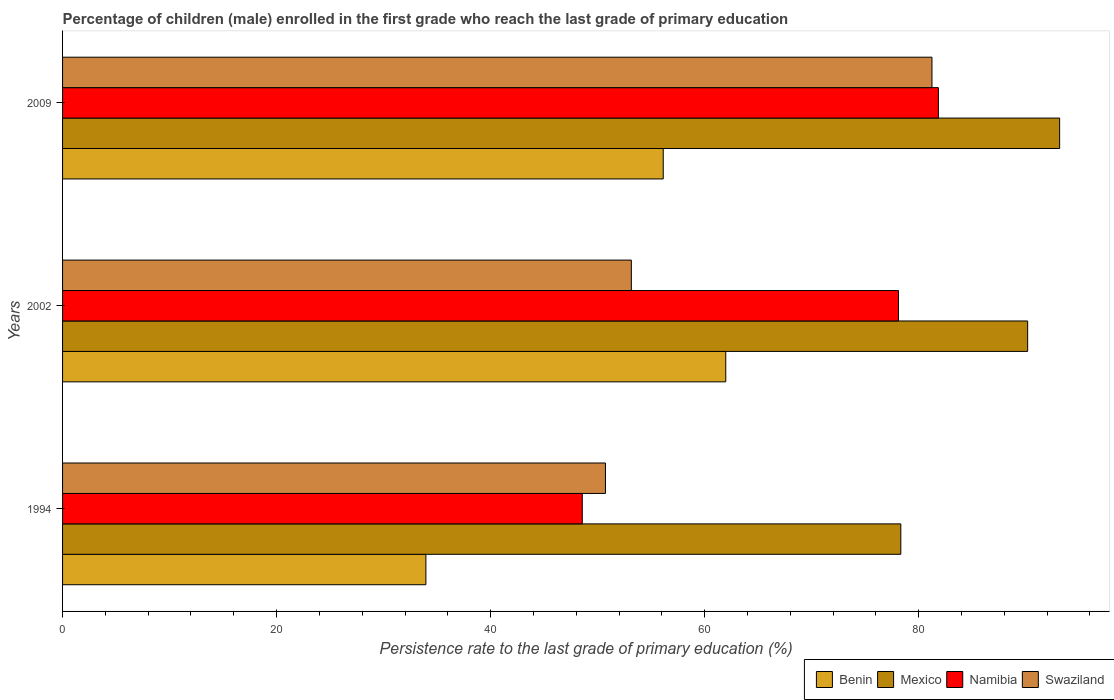How many different coloured bars are there?
Your answer should be compact. 4. Are the number of bars on each tick of the Y-axis equal?
Give a very brief answer. Yes. How many bars are there on the 2nd tick from the top?
Keep it short and to the point. 4. What is the label of the 3rd group of bars from the top?
Provide a short and direct response. 1994. In how many cases, is the number of bars for a given year not equal to the number of legend labels?
Provide a succinct answer. 0. What is the persistence rate of children in Namibia in 2002?
Offer a very short reply. 78.11. Across all years, what is the maximum persistence rate of children in Swaziland?
Offer a very short reply. 81.24. Across all years, what is the minimum persistence rate of children in Mexico?
Give a very brief answer. 78.33. In which year was the persistence rate of children in Swaziland maximum?
Your answer should be compact. 2009. In which year was the persistence rate of children in Benin minimum?
Offer a very short reply. 1994. What is the total persistence rate of children in Swaziland in the graph?
Offer a terse response. 185.12. What is the difference between the persistence rate of children in Benin in 1994 and that in 2009?
Make the answer very short. -22.18. What is the difference between the persistence rate of children in Namibia in 1994 and the persistence rate of children in Mexico in 2009?
Your answer should be compact. -44.61. What is the average persistence rate of children in Benin per year?
Offer a terse response. 50.68. In the year 2009, what is the difference between the persistence rate of children in Swaziland and persistence rate of children in Benin?
Offer a terse response. 25.11. In how many years, is the persistence rate of children in Mexico greater than 76 %?
Provide a short and direct response. 3. What is the ratio of the persistence rate of children in Swaziland in 1994 to that in 2009?
Make the answer very short. 0.62. Is the persistence rate of children in Swaziland in 1994 less than that in 2009?
Keep it short and to the point. Yes. Is the difference between the persistence rate of children in Swaziland in 2002 and 2009 greater than the difference between the persistence rate of children in Benin in 2002 and 2009?
Offer a very short reply. No. What is the difference between the highest and the second highest persistence rate of children in Swaziland?
Offer a terse response. 28.09. What is the difference between the highest and the lowest persistence rate of children in Swaziland?
Ensure brevity in your answer.  30.51. Is the sum of the persistence rate of children in Benin in 1994 and 2002 greater than the maximum persistence rate of children in Swaziland across all years?
Provide a succinct answer. Yes. Is it the case that in every year, the sum of the persistence rate of children in Benin and persistence rate of children in Swaziland is greater than the sum of persistence rate of children in Namibia and persistence rate of children in Mexico?
Give a very brief answer. No. What does the 1st bar from the top in 1994 represents?
Offer a terse response. Swaziland. What does the 4th bar from the bottom in 2009 represents?
Your response must be concise. Swaziland. Is it the case that in every year, the sum of the persistence rate of children in Swaziland and persistence rate of children in Benin is greater than the persistence rate of children in Namibia?
Provide a short and direct response. Yes. How many bars are there?
Keep it short and to the point. 12. Are all the bars in the graph horizontal?
Make the answer very short. Yes. How many years are there in the graph?
Your response must be concise. 3. What is the difference between two consecutive major ticks on the X-axis?
Give a very brief answer. 20. Are the values on the major ticks of X-axis written in scientific E-notation?
Your answer should be compact. No. Does the graph contain grids?
Your answer should be compact. No. How many legend labels are there?
Your response must be concise. 4. What is the title of the graph?
Make the answer very short. Percentage of children (male) enrolled in the first grade who reach the last grade of primary education. What is the label or title of the X-axis?
Give a very brief answer. Persistence rate to the last grade of primary education (%). What is the Persistence rate to the last grade of primary education (%) of Benin in 1994?
Give a very brief answer. 33.95. What is the Persistence rate to the last grade of primary education (%) of Mexico in 1994?
Keep it short and to the point. 78.33. What is the Persistence rate to the last grade of primary education (%) of Namibia in 1994?
Your answer should be very brief. 48.56. What is the Persistence rate to the last grade of primary education (%) of Swaziland in 1994?
Offer a terse response. 50.73. What is the Persistence rate to the last grade of primary education (%) in Benin in 2002?
Offer a very short reply. 61.97. What is the Persistence rate to the last grade of primary education (%) of Mexico in 2002?
Give a very brief answer. 90.18. What is the Persistence rate to the last grade of primary education (%) of Namibia in 2002?
Offer a very short reply. 78.11. What is the Persistence rate to the last grade of primary education (%) of Swaziland in 2002?
Provide a short and direct response. 53.15. What is the Persistence rate to the last grade of primary education (%) of Benin in 2009?
Provide a short and direct response. 56.13. What is the Persistence rate to the last grade of primary education (%) of Mexico in 2009?
Your response must be concise. 93.17. What is the Persistence rate to the last grade of primary education (%) in Namibia in 2009?
Make the answer very short. 81.84. What is the Persistence rate to the last grade of primary education (%) of Swaziland in 2009?
Give a very brief answer. 81.24. Across all years, what is the maximum Persistence rate to the last grade of primary education (%) of Benin?
Make the answer very short. 61.97. Across all years, what is the maximum Persistence rate to the last grade of primary education (%) of Mexico?
Your answer should be very brief. 93.17. Across all years, what is the maximum Persistence rate to the last grade of primary education (%) of Namibia?
Ensure brevity in your answer.  81.84. Across all years, what is the maximum Persistence rate to the last grade of primary education (%) of Swaziland?
Provide a succinct answer. 81.24. Across all years, what is the minimum Persistence rate to the last grade of primary education (%) of Benin?
Ensure brevity in your answer.  33.95. Across all years, what is the minimum Persistence rate to the last grade of primary education (%) in Mexico?
Make the answer very short. 78.33. Across all years, what is the minimum Persistence rate to the last grade of primary education (%) in Namibia?
Make the answer very short. 48.56. Across all years, what is the minimum Persistence rate to the last grade of primary education (%) of Swaziland?
Offer a very short reply. 50.73. What is the total Persistence rate to the last grade of primary education (%) in Benin in the graph?
Provide a succinct answer. 152.05. What is the total Persistence rate to the last grade of primary education (%) of Mexico in the graph?
Offer a terse response. 261.68. What is the total Persistence rate to the last grade of primary education (%) in Namibia in the graph?
Your response must be concise. 208.51. What is the total Persistence rate to the last grade of primary education (%) in Swaziland in the graph?
Offer a terse response. 185.12. What is the difference between the Persistence rate to the last grade of primary education (%) in Benin in 1994 and that in 2002?
Your response must be concise. -28.02. What is the difference between the Persistence rate to the last grade of primary education (%) of Mexico in 1994 and that in 2002?
Offer a terse response. -11.85. What is the difference between the Persistence rate to the last grade of primary education (%) of Namibia in 1994 and that in 2002?
Your response must be concise. -29.55. What is the difference between the Persistence rate to the last grade of primary education (%) of Swaziland in 1994 and that in 2002?
Your answer should be very brief. -2.42. What is the difference between the Persistence rate to the last grade of primary education (%) in Benin in 1994 and that in 2009?
Your response must be concise. -22.18. What is the difference between the Persistence rate to the last grade of primary education (%) of Mexico in 1994 and that in 2009?
Give a very brief answer. -14.84. What is the difference between the Persistence rate to the last grade of primary education (%) of Namibia in 1994 and that in 2009?
Provide a succinct answer. -33.28. What is the difference between the Persistence rate to the last grade of primary education (%) of Swaziland in 1994 and that in 2009?
Provide a short and direct response. -30.51. What is the difference between the Persistence rate to the last grade of primary education (%) of Benin in 2002 and that in 2009?
Ensure brevity in your answer.  5.84. What is the difference between the Persistence rate to the last grade of primary education (%) of Mexico in 2002 and that in 2009?
Provide a short and direct response. -2.99. What is the difference between the Persistence rate to the last grade of primary education (%) in Namibia in 2002 and that in 2009?
Make the answer very short. -3.73. What is the difference between the Persistence rate to the last grade of primary education (%) in Swaziland in 2002 and that in 2009?
Give a very brief answer. -28.09. What is the difference between the Persistence rate to the last grade of primary education (%) in Benin in 1994 and the Persistence rate to the last grade of primary education (%) in Mexico in 2002?
Provide a short and direct response. -56.23. What is the difference between the Persistence rate to the last grade of primary education (%) in Benin in 1994 and the Persistence rate to the last grade of primary education (%) in Namibia in 2002?
Offer a very short reply. -44.16. What is the difference between the Persistence rate to the last grade of primary education (%) of Benin in 1994 and the Persistence rate to the last grade of primary education (%) of Swaziland in 2002?
Keep it short and to the point. -19.2. What is the difference between the Persistence rate to the last grade of primary education (%) in Mexico in 1994 and the Persistence rate to the last grade of primary education (%) in Namibia in 2002?
Your answer should be compact. 0.22. What is the difference between the Persistence rate to the last grade of primary education (%) in Mexico in 1994 and the Persistence rate to the last grade of primary education (%) in Swaziland in 2002?
Your answer should be compact. 25.18. What is the difference between the Persistence rate to the last grade of primary education (%) in Namibia in 1994 and the Persistence rate to the last grade of primary education (%) in Swaziland in 2002?
Your answer should be very brief. -4.59. What is the difference between the Persistence rate to the last grade of primary education (%) in Benin in 1994 and the Persistence rate to the last grade of primary education (%) in Mexico in 2009?
Make the answer very short. -59.22. What is the difference between the Persistence rate to the last grade of primary education (%) in Benin in 1994 and the Persistence rate to the last grade of primary education (%) in Namibia in 2009?
Your response must be concise. -47.89. What is the difference between the Persistence rate to the last grade of primary education (%) of Benin in 1994 and the Persistence rate to the last grade of primary education (%) of Swaziland in 2009?
Make the answer very short. -47.29. What is the difference between the Persistence rate to the last grade of primary education (%) of Mexico in 1994 and the Persistence rate to the last grade of primary education (%) of Namibia in 2009?
Give a very brief answer. -3.51. What is the difference between the Persistence rate to the last grade of primary education (%) of Mexico in 1994 and the Persistence rate to the last grade of primary education (%) of Swaziland in 2009?
Provide a succinct answer. -2.91. What is the difference between the Persistence rate to the last grade of primary education (%) in Namibia in 1994 and the Persistence rate to the last grade of primary education (%) in Swaziland in 2009?
Your answer should be compact. -32.68. What is the difference between the Persistence rate to the last grade of primary education (%) of Benin in 2002 and the Persistence rate to the last grade of primary education (%) of Mexico in 2009?
Offer a terse response. -31.2. What is the difference between the Persistence rate to the last grade of primary education (%) of Benin in 2002 and the Persistence rate to the last grade of primary education (%) of Namibia in 2009?
Provide a succinct answer. -19.87. What is the difference between the Persistence rate to the last grade of primary education (%) in Benin in 2002 and the Persistence rate to the last grade of primary education (%) in Swaziland in 2009?
Your response must be concise. -19.27. What is the difference between the Persistence rate to the last grade of primary education (%) in Mexico in 2002 and the Persistence rate to the last grade of primary education (%) in Namibia in 2009?
Keep it short and to the point. 8.34. What is the difference between the Persistence rate to the last grade of primary education (%) in Mexico in 2002 and the Persistence rate to the last grade of primary education (%) in Swaziland in 2009?
Your answer should be compact. 8.94. What is the difference between the Persistence rate to the last grade of primary education (%) of Namibia in 2002 and the Persistence rate to the last grade of primary education (%) of Swaziland in 2009?
Offer a very short reply. -3.13. What is the average Persistence rate to the last grade of primary education (%) of Benin per year?
Ensure brevity in your answer.  50.68. What is the average Persistence rate to the last grade of primary education (%) in Mexico per year?
Your answer should be very brief. 87.22. What is the average Persistence rate to the last grade of primary education (%) in Namibia per year?
Offer a terse response. 69.5. What is the average Persistence rate to the last grade of primary education (%) in Swaziland per year?
Offer a very short reply. 61.7. In the year 1994, what is the difference between the Persistence rate to the last grade of primary education (%) in Benin and Persistence rate to the last grade of primary education (%) in Mexico?
Give a very brief answer. -44.38. In the year 1994, what is the difference between the Persistence rate to the last grade of primary education (%) of Benin and Persistence rate to the last grade of primary education (%) of Namibia?
Your answer should be compact. -14.61. In the year 1994, what is the difference between the Persistence rate to the last grade of primary education (%) of Benin and Persistence rate to the last grade of primary education (%) of Swaziland?
Your answer should be compact. -16.78. In the year 1994, what is the difference between the Persistence rate to the last grade of primary education (%) in Mexico and Persistence rate to the last grade of primary education (%) in Namibia?
Your answer should be compact. 29.76. In the year 1994, what is the difference between the Persistence rate to the last grade of primary education (%) of Mexico and Persistence rate to the last grade of primary education (%) of Swaziland?
Offer a terse response. 27.6. In the year 1994, what is the difference between the Persistence rate to the last grade of primary education (%) of Namibia and Persistence rate to the last grade of primary education (%) of Swaziland?
Your response must be concise. -2.16. In the year 2002, what is the difference between the Persistence rate to the last grade of primary education (%) of Benin and Persistence rate to the last grade of primary education (%) of Mexico?
Make the answer very short. -28.21. In the year 2002, what is the difference between the Persistence rate to the last grade of primary education (%) of Benin and Persistence rate to the last grade of primary education (%) of Namibia?
Your answer should be very brief. -16.14. In the year 2002, what is the difference between the Persistence rate to the last grade of primary education (%) in Benin and Persistence rate to the last grade of primary education (%) in Swaziland?
Make the answer very short. 8.82. In the year 2002, what is the difference between the Persistence rate to the last grade of primary education (%) in Mexico and Persistence rate to the last grade of primary education (%) in Namibia?
Keep it short and to the point. 12.07. In the year 2002, what is the difference between the Persistence rate to the last grade of primary education (%) in Mexico and Persistence rate to the last grade of primary education (%) in Swaziland?
Ensure brevity in your answer.  37.03. In the year 2002, what is the difference between the Persistence rate to the last grade of primary education (%) of Namibia and Persistence rate to the last grade of primary education (%) of Swaziland?
Ensure brevity in your answer.  24.96. In the year 2009, what is the difference between the Persistence rate to the last grade of primary education (%) of Benin and Persistence rate to the last grade of primary education (%) of Mexico?
Offer a very short reply. -37.04. In the year 2009, what is the difference between the Persistence rate to the last grade of primary education (%) of Benin and Persistence rate to the last grade of primary education (%) of Namibia?
Your answer should be compact. -25.71. In the year 2009, what is the difference between the Persistence rate to the last grade of primary education (%) of Benin and Persistence rate to the last grade of primary education (%) of Swaziland?
Your answer should be compact. -25.11. In the year 2009, what is the difference between the Persistence rate to the last grade of primary education (%) of Mexico and Persistence rate to the last grade of primary education (%) of Namibia?
Offer a very short reply. 11.33. In the year 2009, what is the difference between the Persistence rate to the last grade of primary education (%) of Mexico and Persistence rate to the last grade of primary education (%) of Swaziland?
Your answer should be compact. 11.93. In the year 2009, what is the difference between the Persistence rate to the last grade of primary education (%) in Namibia and Persistence rate to the last grade of primary education (%) in Swaziland?
Your answer should be compact. 0.6. What is the ratio of the Persistence rate to the last grade of primary education (%) of Benin in 1994 to that in 2002?
Your answer should be very brief. 0.55. What is the ratio of the Persistence rate to the last grade of primary education (%) in Mexico in 1994 to that in 2002?
Provide a succinct answer. 0.87. What is the ratio of the Persistence rate to the last grade of primary education (%) in Namibia in 1994 to that in 2002?
Offer a very short reply. 0.62. What is the ratio of the Persistence rate to the last grade of primary education (%) of Swaziland in 1994 to that in 2002?
Ensure brevity in your answer.  0.95. What is the ratio of the Persistence rate to the last grade of primary education (%) of Benin in 1994 to that in 2009?
Your answer should be compact. 0.6. What is the ratio of the Persistence rate to the last grade of primary education (%) in Mexico in 1994 to that in 2009?
Give a very brief answer. 0.84. What is the ratio of the Persistence rate to the last grade of primary education (%) of Namibia in 1994 to that in 2009?
Make the answer very short. 0.59. What is the ratio of the Persistence rate to the last grade of primary education (%) of Swaziland in 1994 to that in 2009?
Your response must be concise. 0.62. What is the ratio of the Persistence rate to the last grade of primary education (%) of Benin in 2002 to that in 2009?
Offer a terse response. 1.1. What is the ratio of the Persistence rate to the last grade of primary education (%) in Mexico in 2002 to that in 2009?
Your answer should be very brief. 0.97. What is the ratio of the Persistence rate to the last grade of primary education (%) of Namibia in 2002 to that in 2009?
Your response must be concise. 0.95. What is the ratio of the Persistence rate to the last grade of primary education (%) of Swaziland in 2002 to that in 2009?
Your response must be concise. 0.65. What is the difference between the highest and the second highest Persistence rate to the last grade of primary education (%) in Benin?
Provide a succinct answer. 5.84. What is the difference between the highest and the second highest Persistence rate to the last grade of primary education (%) in Mexico?
Ensure brevity in your answer.  2.99. What is the difference between the highest and the second highest Persistence rate to the last grade of primary education (%) of Namibia?
Make the answer very short. 3.73. What is the difference between the highest and the second highest Persistence rate to the last grade of primary education (%) in Swaziland?
Offer a very short reply. 28.09. What is the difference between the highest and the lowest Persistence rate to the last grade of primary education (%) in Benin?
Provide a short and direct response. 28.02. What is the difference between the highest and the lowest Persistence rate to the last grade of primary education (%) in Mexico?
Your answer should be very brief. 14.84. What is the difference between the highest and the lowest Persistence rate to the last grade of primary education (%) in Namibia?
Your answer should be compact. 33.28. What is the difference between the highest and the lowest Persistence rate to the last grade of primary education (%) of Swaziland?
Keep it short and to the point. 30.51. 